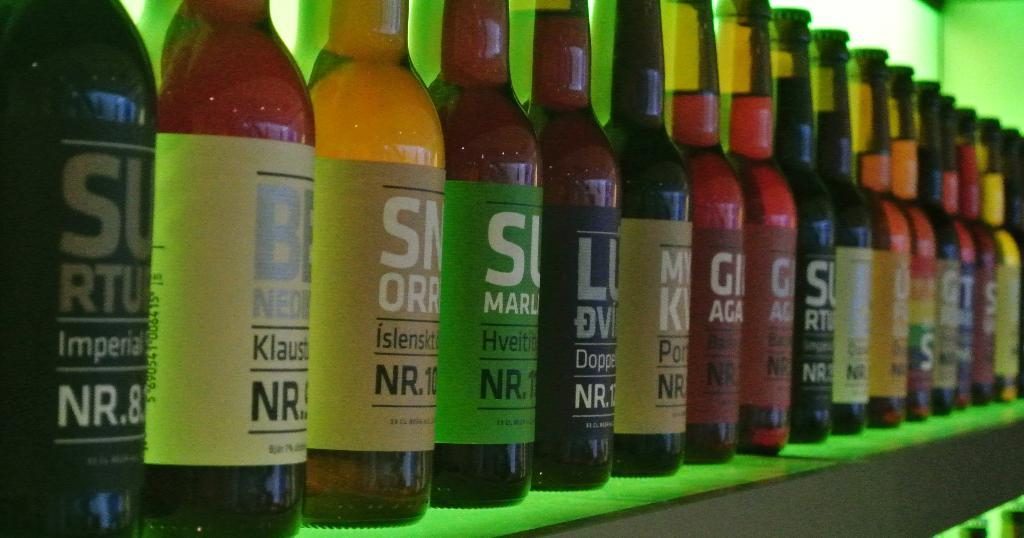What is on the table in the image? There are wine bottles on the table. What can be seen in the background of the image? There is a wall in the background of the image. What type of machine is being used to create motion in the image? There is no machine present in the image, and no motion is depicted. 